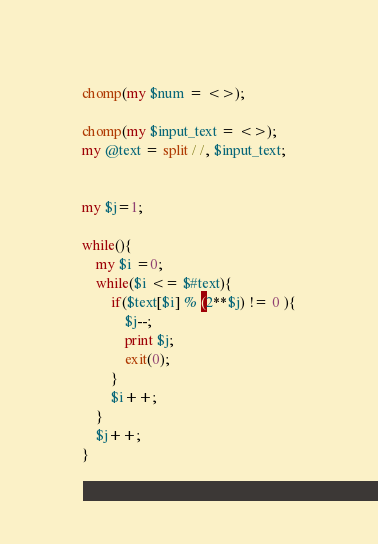<code> <loc_0><loc_0><loc_500><loc_500><_Perl_>chomp(my $num = <>);

chomp(my $input_text = <>);
my @text = split / /, $input_text;


my $j=1;

while(){
    my $i =0;
    while($i <= $#text){
        if($text[$i] % (2**$j) != 0 ){
            $j--;
            print $j;
            exit(0);
        }
        $i++;
    }
    $j++;
}</code> 